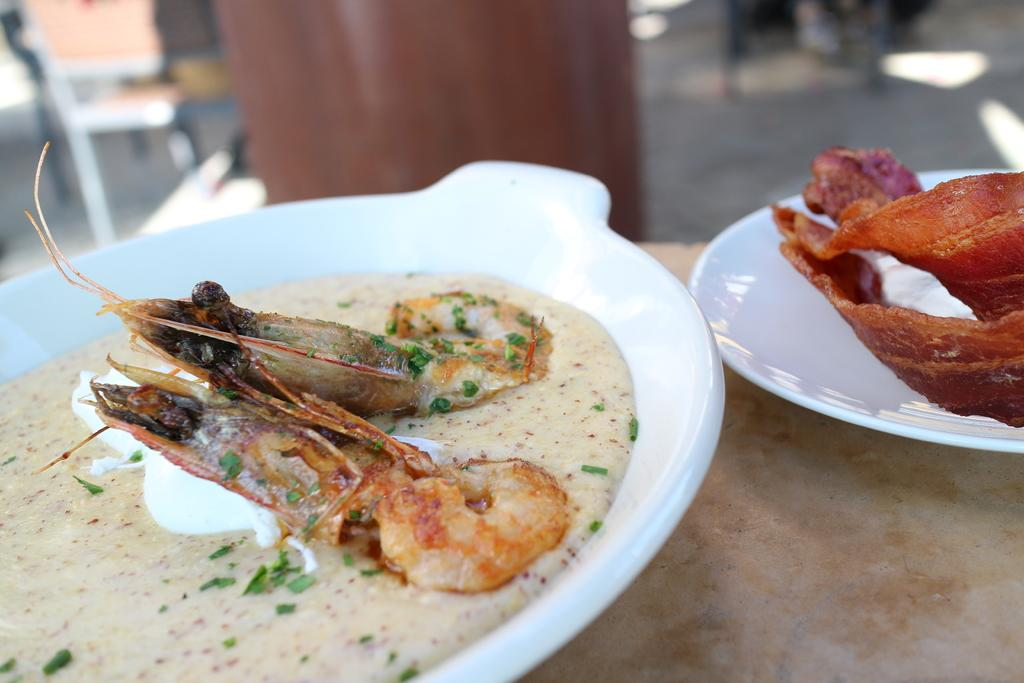What objects are on the surface in the image? There are two white plates on a surface in the image. What is on the plates? There are food items on the plates. Can you describe one of the food items in more detail? One of the food items has prawns with white cream on it. What can be observed about the background of the image? The background of the image is blurred. What type of apparel is being worn by the prawns in the image? There are no prawns wearing apparel in the image; the prawns are part of a food item. What is the process of rubbing the plates in the image? There is no rubbing of the plates depicted in the image; the plates are stationary on a surface. 